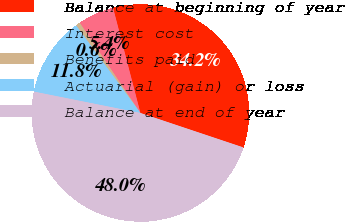Convert chart to OTSL. <chart><loc_0><loc_0><loc_500><loc_500><pie_chart><fcel>Balance at beginning of year<fcel>Interest cost<fcel>Benefits paid<fcel>Actuarial (gain) or loss<fcel>Balance at end of year<nl><fcel>34.19%<fcel>5.38%<fcel>0.65%<fcel>11.77%<fcel>48.01%<nl></chart> 